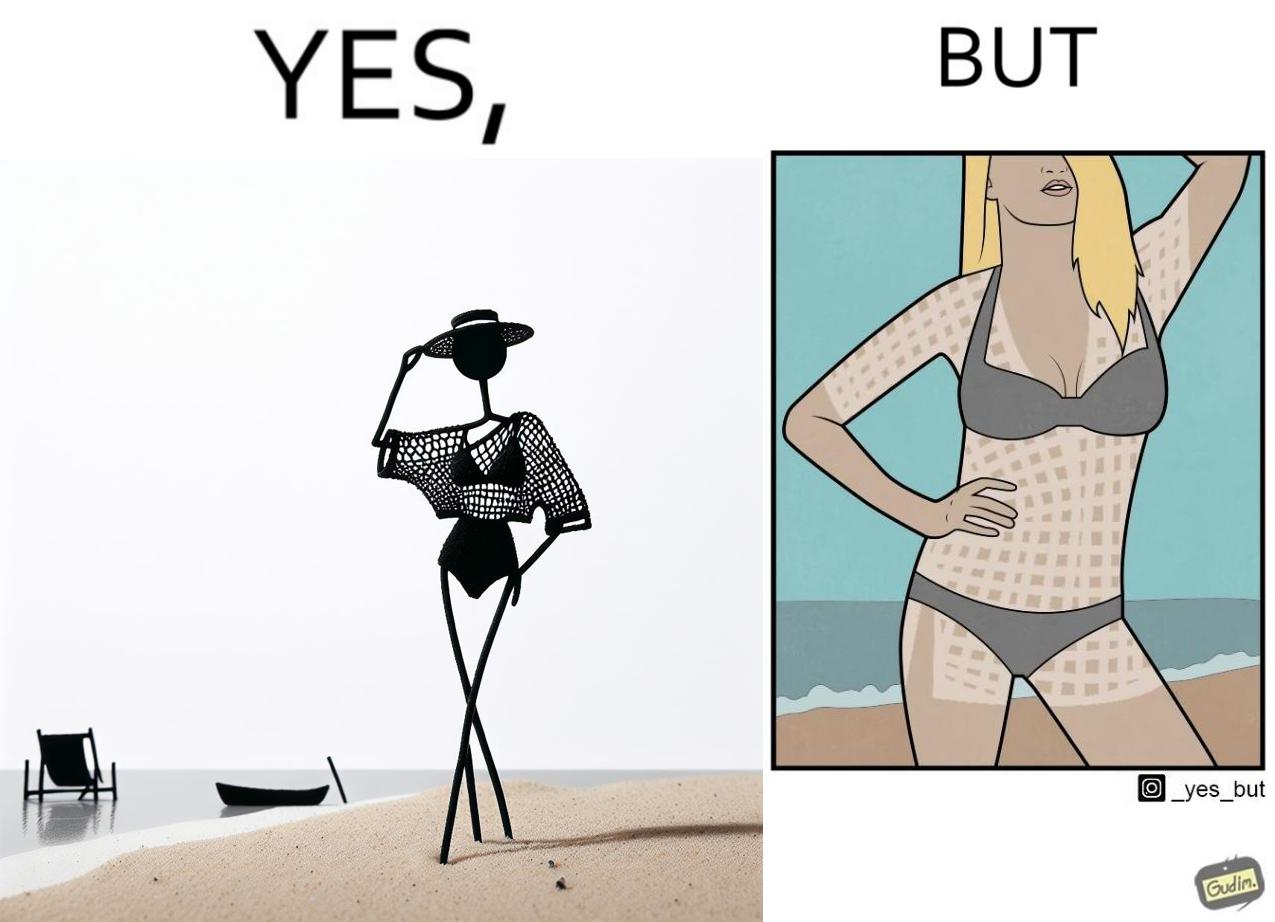Compare the left and right sides of this image. In the left part of the image: a woman wearing a netted top over bikini posing for some photo at beach In the right part of the image: a woman wearing bikini, with tanned body in some spots, posing for some photo at beach 